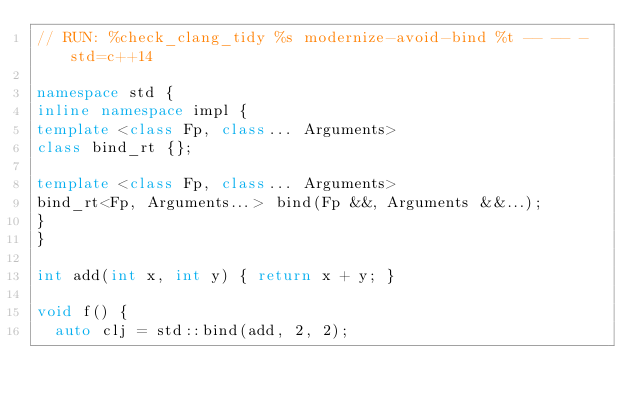<code> <loc_0><loc_0><loc_500><loc_500><_C++_>// RUN: %check_clang_tidy %s modernize-avoid-bind %t -- -- -std=c++14

namespace std {
inline namespace impl {
template <class Fp, class... Arguments>
class bind_rt {};

template <class Fp, class... Arguments>
bind_rt<Fp, Arguments...> bind(Fp &&, Arguments &&...);
}
}

int add(int x, int y) { return x + y; }

void f() {
  auto clj = std::bind(add, 2, 2);</code> 